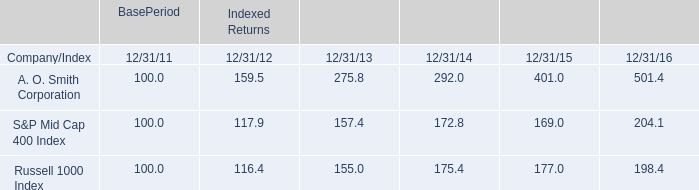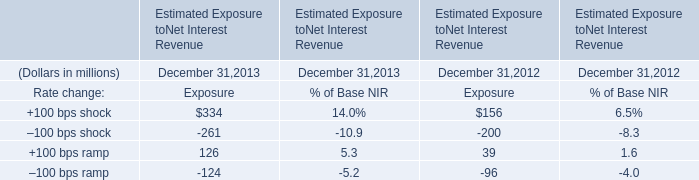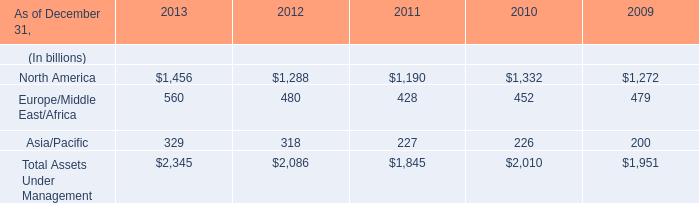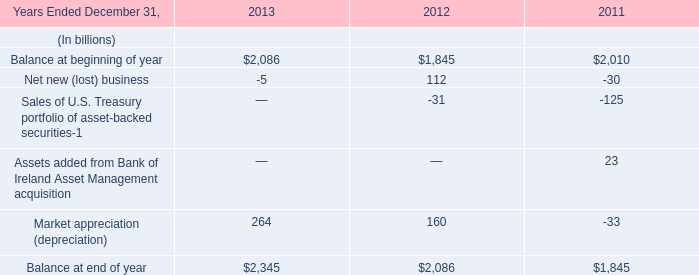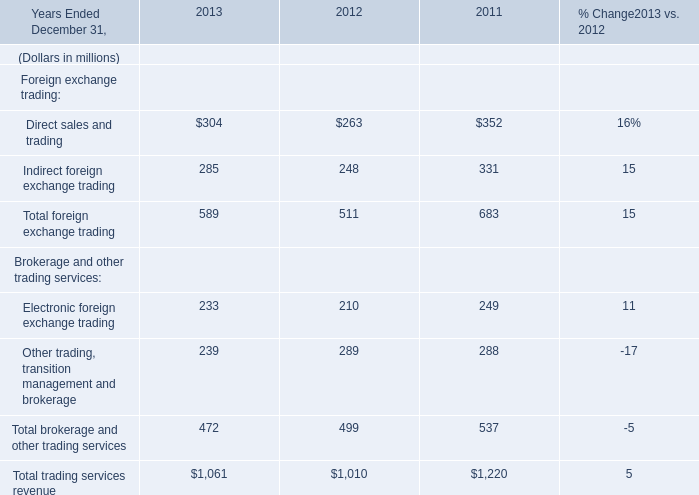In the year with largest amount of Other trading, transition management and brokerage, what's the increasing rate of Total foreign exchange trading? (in %) 
Computations: ((511 - 683) / 683)
Answer: -0.25183. 